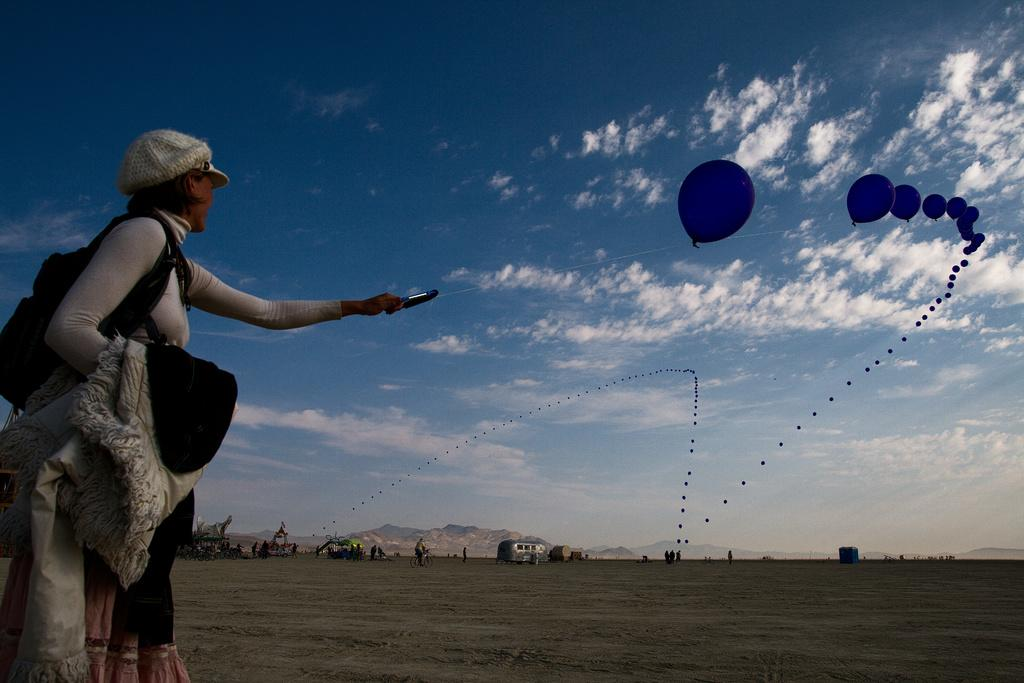What is the person in the image holding? The person is holding a wire bag and cloth in their hand. What else can be seen in the image besides the person? There are balloons in the air, and the background includes people and hills. What is visible in the sky in the image? The sky is visible in the background of the image. Can you see a ghost in the image? No, there is no ghost present in the image. What direction is the wind blowing in the image? There is no indication of wind in the image, so it cannot be determined from the image. 